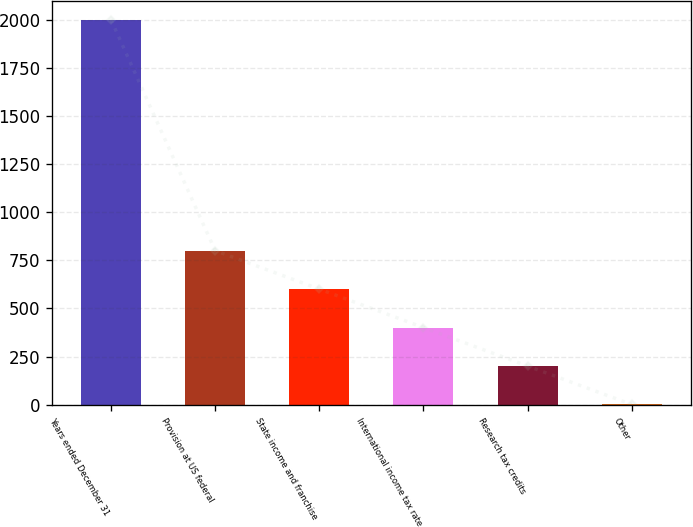<chart> <loc_0><loc_0><loc_500><loc_500><bar_chart><fcel>Years ended December 31<fcel>Provision at US federal<fcel>State income and franchise<fcel>International income tax rate<fcel>Research tax credits<fcel>Other<nl><fcel>2002<fcel>801.04<fcel>600.88<fcel>400.72<fcel>200.56<fcel>0.4<nl></chart> 